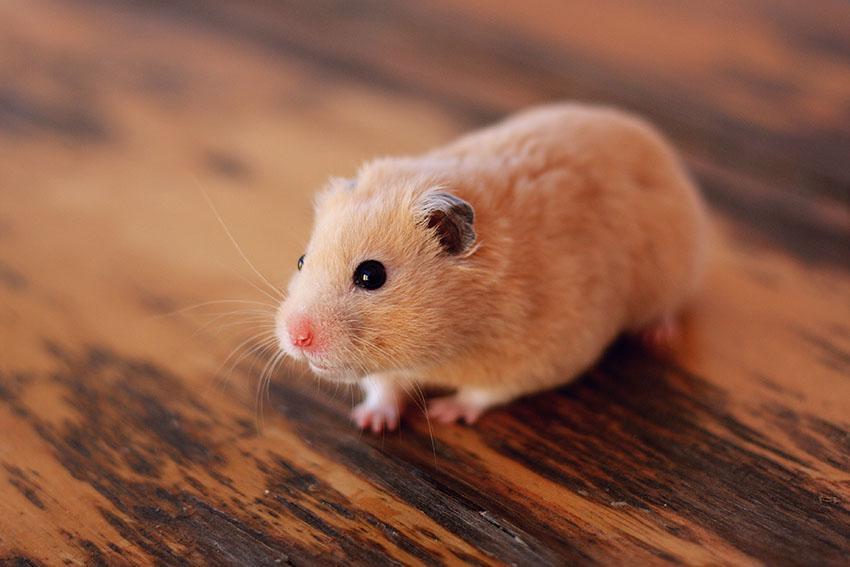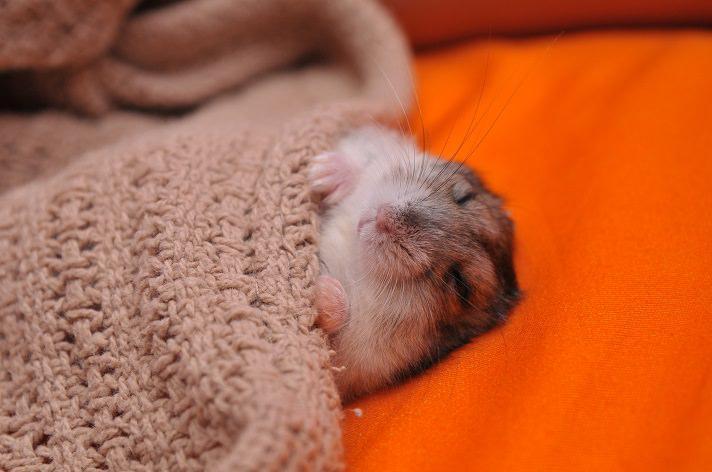The first image is the image on the left, the second image is the image on the right. For the images displayed, is the sentence "The rodent in one of the images is covered by a blanket." factually correct? Answer yes or no. Yes. 